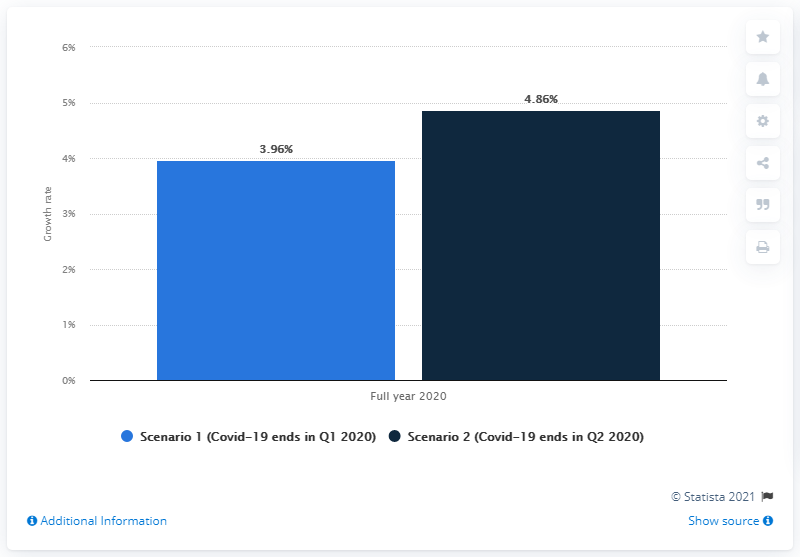Draw attention to some important aspects in this diagram. The projected increase in the Consumer Price Index (CPI) if the COVID-19 outbreak was contained in the second quarter of 2020 was 4.86%. 